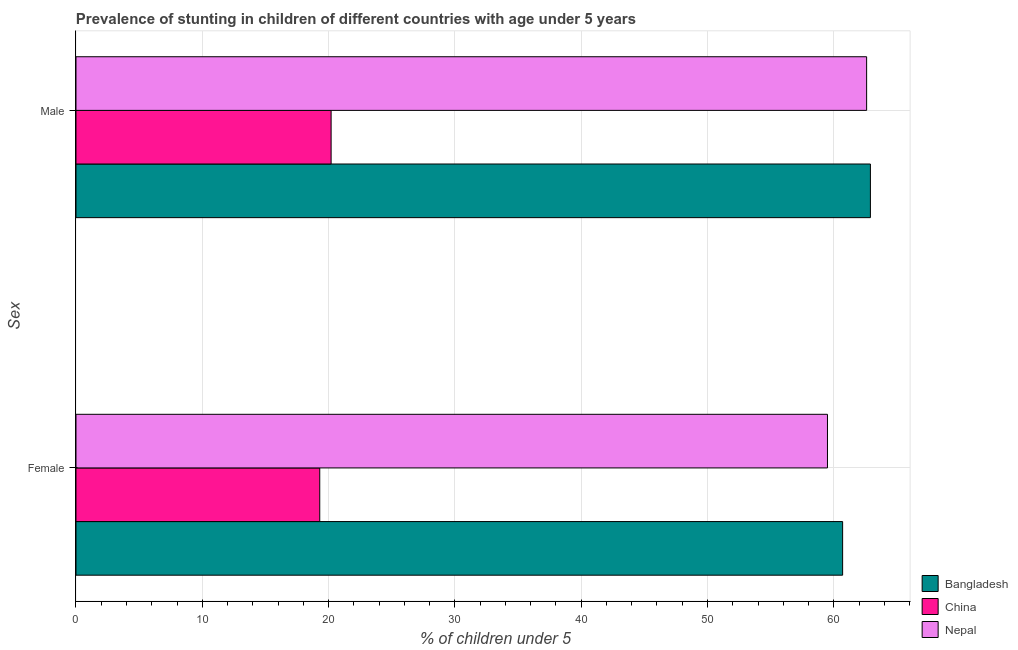How many groups of bars are there?
Provide a short and direct response. 2. What is the label of the 2nd group of bars from the top?
Provide a short and direct response. Female. What is the percentage of stunted male children in Bangladesh?
Provide a succinct answer. 62.9. Across all countries, what is the maximum percentage of stunted male children?
Give a very brief answer. 62.9. Across all countries, what is the minimum percentage of stunted female children?
Provide a succinct answer. 19.3. In which country was the percentage of stunted male children maximum?
Your answer should be very brief. Bangladesh. In which country was the percentage of stunted male children minimum?
Make the answer very short. China. What is the total percentage of stunted female children in the graph?
Provide a succinct answer. 139.5. What is the difference between the percentage of stunted male children in China and that in Nepal?
Your response must be concise. -42.4. What is the difference between the percentage of stunted male children in Bangladesh and the percentage of stunted female children in Nepal?
Your answer should be compact. 3.4. What is the average percentage of stunted female children per country?
Make the answer very short. 46.5. What is the difference between the percentage of stunted male children and percentage of stunted female children in China?
Offer a very short reply. 0.9. In how many countries, is the percentage of stunted female children greater than 38 %?
Ensure brevity in your answer.  2. What is the ratio of the percentage of stunted male children in China to that in Nepal?
Provide a short and direct response. 0.32. Is the percentage of stunted male children in Nepal less than that in Bangladesh?
Keep it short and to the point. Yes. What does the 1st bar from the top in Male represents?
Your response must be concise. Nepal. What does the 1st bar from the bottom in Male represents?
Offer a very short reply. Bangladesh. How many bars are there?
Keep it short and to the point. 6. Are all the bars in the graph horizontal?
Offer a very short reply. Yes. How many countries are there in the graph?
Your answer should be compact. 3. Are the values on the major ticks of X-axis written in scientific E-notation?
Your response must be concise. No. Does the graph contain any zero values?
Offer a terse response. No. Does the graph contain grids?
Make the answer very short. Yes. What is the title of the graph?
Provide a succinct answer. Prevalence of stunting in children of different countries with age under 5 years. Does "Kazakhstan" appear as one of the legend labels in the graph?
Your answer should be very brief. No. What is the label or title of the X-axis?
Provide a succinct answer.  % of children under 5. What is the label or title of the Y-axis?
Offer a very short reply. Sex. What is the  % of children under 5 in Bangladesh in Female?
Provide a succinct answer. 60.7. What is the  % of children under 5 of China in Female?
Your answer should be compact. 19.3. What is the  % of children under 5 of Nepal in Female?
Your response must be concise. 59.5. What is the  % of children under 5 in Bangladesh in Male?
Make the answer very short. 62.9. What is the  % of children under 5 of China in Male?
Offer a terse response. 20.2. What is the  % of children under 5 in Nepal in Male?
Your response must be concise. 62.6. Across all Sex, what is the maximum  % of children under 5 in Bangladesh?
Ensure brevity in your answer.  62.9. Across all Sex, what is the maximum  % of children under 5 in China?
Your answer should be very brief. 20.2. Across all Sex, what is the maximum  % of children under 5 in Nepal?
Offer a very short reply. 62.6. Across all Sex, what is the minimum  % of children under 5 in Bangladesh?
Provide a succinct answer. 60.7. Across all Sex, what is the minimum  % of children under 5 in China?
Offer a terse response. 19.3. Across all Sex, what is the minimum  % of children under 5 in Nepal?
Your response must be concise. 59.5. What is the total  % of children under 5 in Bangladesh in the graph?
Give a very brief answer. 123.6. What is the total  % of children under 5 of China in the graph?
Keep it short and to the point. 39.5. What is the total  % of children under 5 of Nepal in the graph?
Make the answer very short. 122.1. What is the difference between the  % of children under 5 of Bangladesh in Female and that in Male?
Provide a succinct answer. -2.2. What is the difference between the  % of children under 5 of China in Female and that in Male?
Provide a succinct answer. -0.9. What is the difference between the  % of children under 5 of Bangladesh in Female and the  % of children under 5 of China in Male?
Make the answer very short. 40.5. What is the difference between the  % of children under 5 of Bangladesh in Female and the  % of children under 5 of Nepal in Male?
Your answer should be compact. -1.9. What is the difference between the  % of children under 5 of China in Female and the  % of children under 5 of Nepal in Male?
Your answer should be compact. -43.3. What is the average  % of children under 5 in Bangladesh per Sex?
Give a very brief answer. 61.8. What is the average  % of children under 5 in China per Sex?
Offer a very short reply. 19.75. What is the average  % of children under 5 of Nepal per Sex?
Provide a short and direct response. 61.05. What is the difference between the  % of children under 5 in Bangladesh and  % of children under 5 in China in Female?
Offer a terse response. 41.4. What is the difference between the  % of children under 5 in Bangladesh and  % of children under 5 in Nepal in Female?
Provide a succinct answer. 1.2. What is the difference between the  % of children under 5 of China and  % of children under 5 of Nepal in Female?
Ensure brevity in your answer.  -40.2. What is the difference between the  % of children under 5 of Bangladesh and  % of children under 5 of China in Male?
Your response must be concise. 42.7. What is the difference between the  % of children under 5 of Bangladesh and  % of children under 5 of Nepal in Male?
Give a very brief answer. 0.3. What is the difference between the  % of children under 5 of China and  % of children under 5 of Nepal in Male?
Offer a terse response. -42.4. What is the ratio of the  % of children under 5 in China in Female to that in Male?
Your answer should be compact. 0.96. What is the ratio of the  % of children under 5 in Nepal in Female to that in Male?
Give a very brief answer. 0.95. What is the difference between the highest and the second highest  % of children under 5 in Bangladesh?
Your response must be concise. 2.2. What is the difference between the highest and the lowest  % of children under 5 of China?
Provide a succinct answer. 0.9. What is the difference between the highest and the lowest  % of children under 5 in Nepal?
Ensure brevity in your answer.  3.1. 